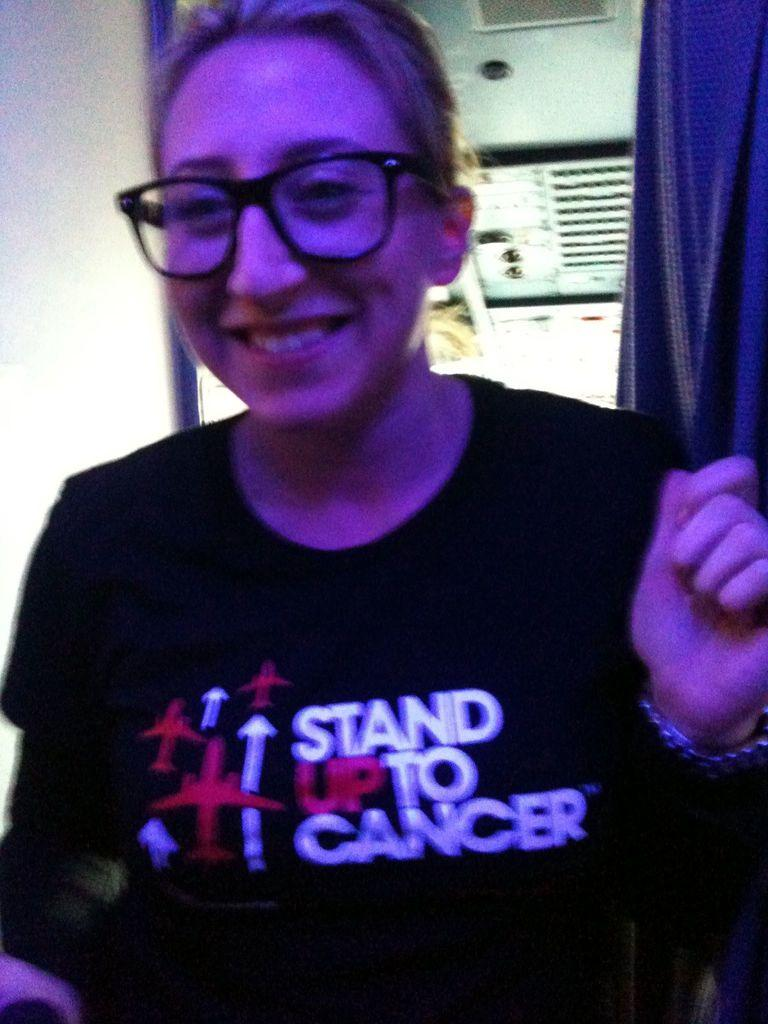Who or what is present in the image? There is a person in the image. What can be observed about the person's appearance? The person is wearing spectacles. What type of covering is present in the image? There is a curtain in the image. Can you describe the background of the image? There is an object in the background of the image. How does the person in the image interact with the nest? There is no nest present in the image, so the person cannot interact with it. 